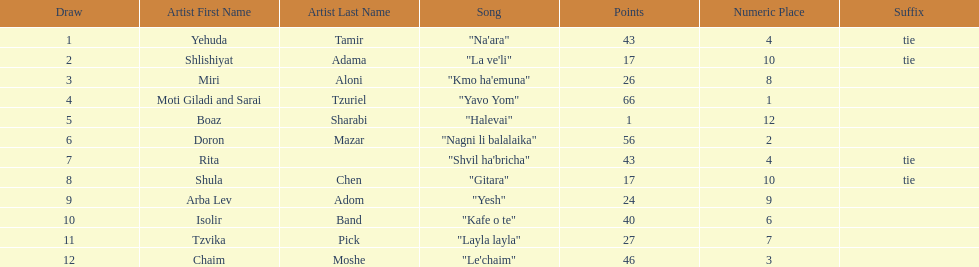What is the total amount of ties in this competition? 2. 